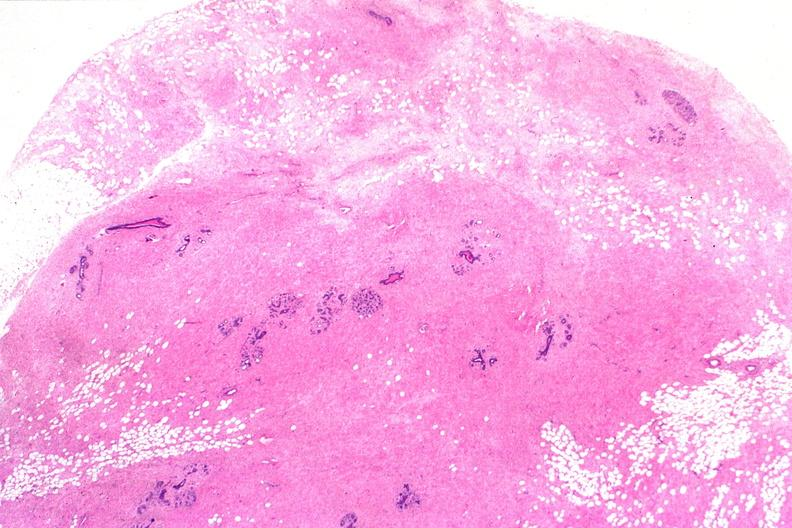s endocrine present?
Answer the question using a single word or phrase. No 